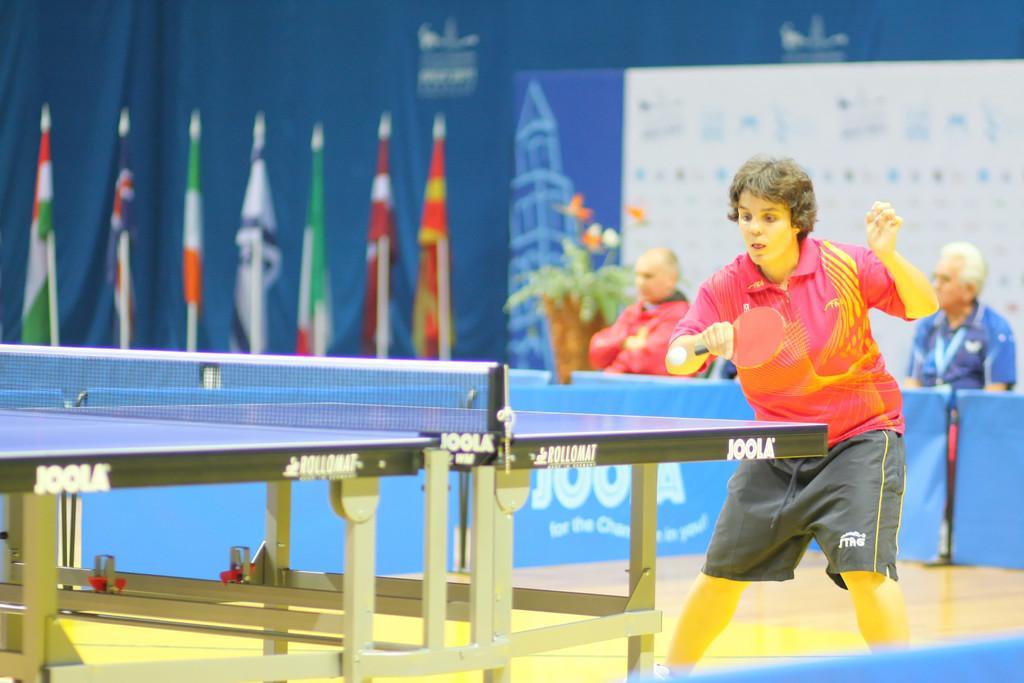Please provide a concise description of this image. In this image i can see a person wearing red t shirt and black short standing and holding a bat in his hand, i can see a ball over here and a table tennis. In the background i can see few flags, 2 persons and the board. 